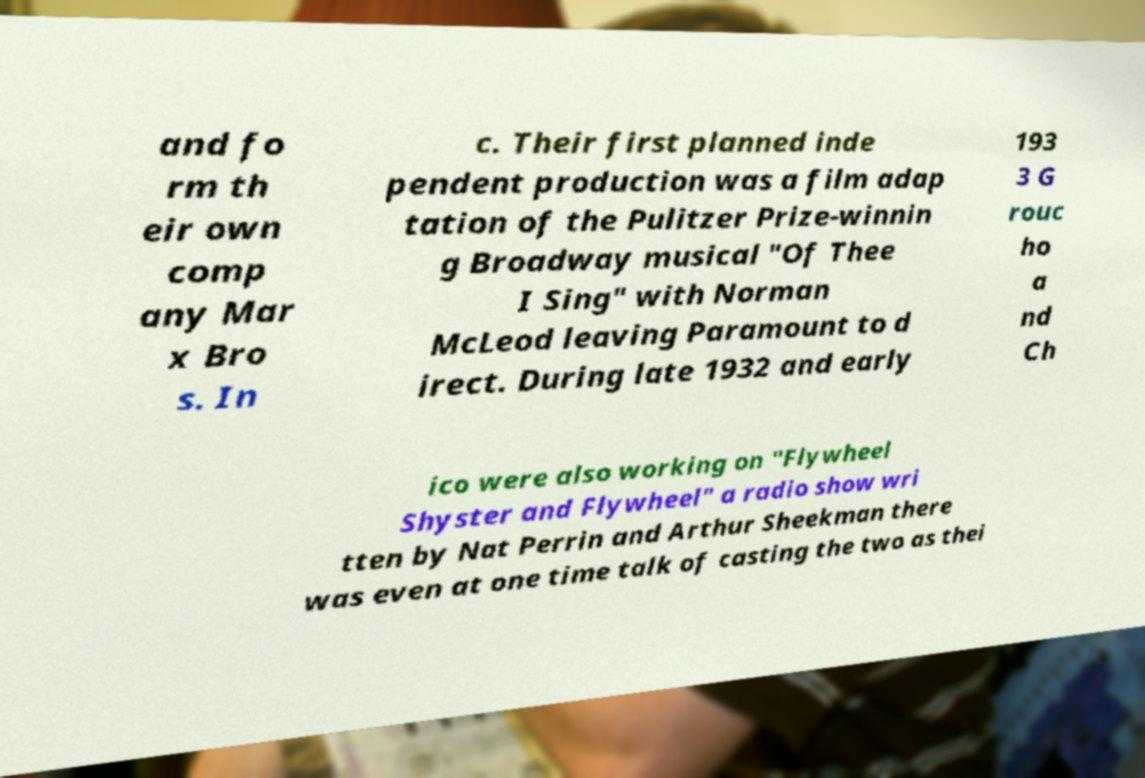I need the written content from this picture converted into text. Can you do that? and fo rm th eir own comp any Mar x Bro s. In c. Their first planned inde pendent production was a film adap tation of the Pulitzer Prize-winnin g Broadway musical "Of Thee I Sing" with Norman McLeod leaving Paramount to d irect. During late 1932 and early 193 3 G rouc ho a nd Ch ico were also working on "Flywheel Shyster and Flywheel" a radio show wri tten by Nat Perrin and Arthur Sheekman there was even at one time talk of casting the two as thei 